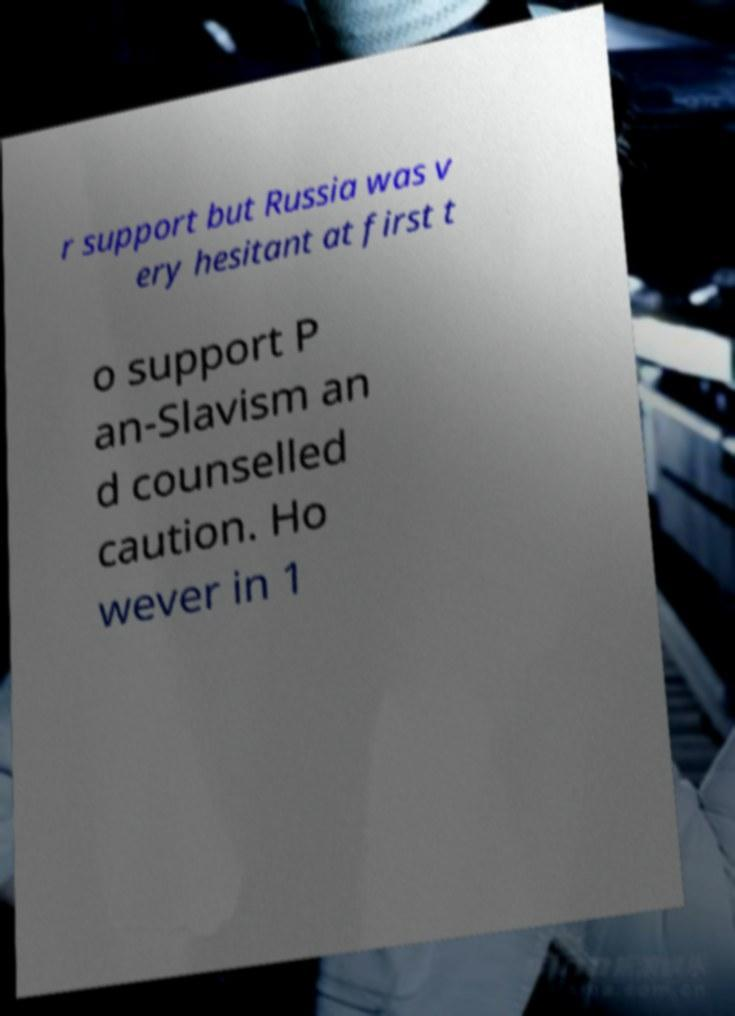There's text embedded in this image that I need extracted. Can you transcribe it verbatim? r support but Russia was v ery hesitant at first t o support P an-Slavism an d counselled caution. Ho wever in 1 